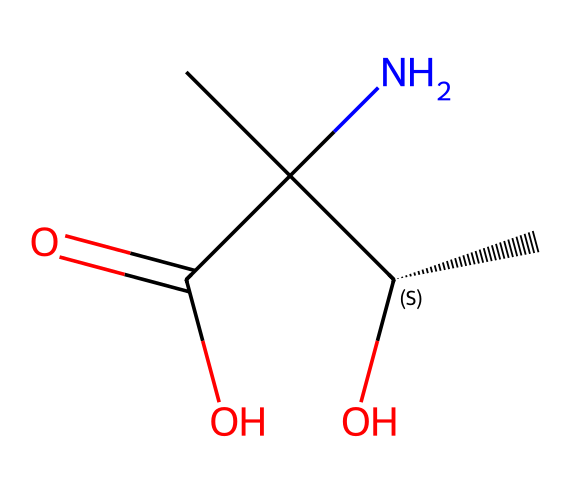What is the molecular formula of this compound? By analyzing the SMILES representation, we can determine the number of each type of atom present: Carbon (C), Hydrogen (H), Nitrogen (N), and Oxygen (O). The formula counts from the structure indicate that there are 6 Carbon atoms, 13 Hydrogen atoms, 1 Nitrogen atom, and 2 Oxygen atoms. Thus, the molecular formula can be written as C6H13N1O2.
Answer: C6H13NO2 How many stereocenters are in the molecule? A stereocenter is defined as a carbon atom bonded to four different substituents. Looking at the structure from the SMILES, we can identify that there is one carbon atom with four distinct groups attached (the chiral center at C@H), making it a stereocenter.
Answer: 1 What functional groups are present in the molecule? The key functional groups can be identified by analyzing the different parts of the structure. The molecule contains an amine group (due to the presence of the nitrogen atom bonded to carbon), a carboxylic acid (due to the -C(=O)O part), and an alcohol group (due to the -OH).
Answer: amine, carboxylic acid, alcohol What is the significance of chirality in this compound? Chirality is significant because it means that this compound can exist in two enantiomeric forms that may interact differently with biological systems or materials in silicon wafer processing. The specific arrangement affects the reactivity and effectiveness of the etchant.
Answer: different reactivity What type of interaction would this compound most likely prefer with silicon surfaces? Given that the functional groups include amine and carboxylic acid, the compound is likely to interact with silicon surfaces via hydrogen bonding and possibly coordinate bond interactions with the silicon. This is due to the electron-donating characteristics of the amine and carboxylate groups.
Answer: hydrogen bonding What type of isomerism is exhibited by this compound? The compound exhibits optical isomerism due to the presence of its single chiral center, leading to two enantiomers that are non-superimposable mirror images of each other. This uniqueness is critical for applications that require specific configurations for their effectiveness.
Answer: optical isomerism How many total atoms are in this molecule? We can tally the atoms from the previously identified molecular formula. The total number of atoms is the sum of Carbon (6), Hydrogen (13), Nitrogen (1), and Oxygen (2), giving us a total of 22 atoms in this molecule.
Answer: 22 